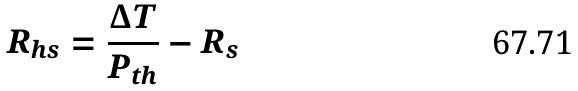<formula> <loc_0><loc_0><loc_500><loc_500>R _ { h s } = \frac { \Delta T } { P _ { t h } } - R _ { s }</formula> 